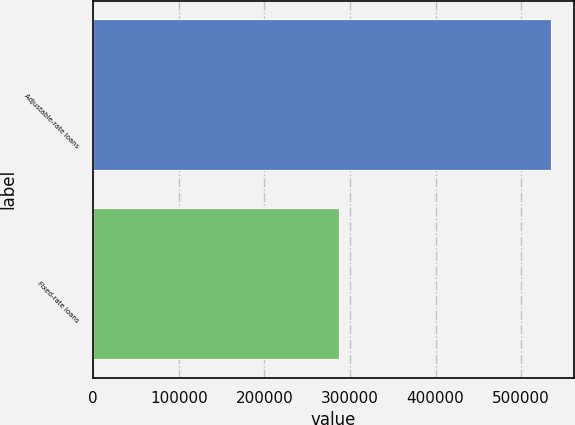<chart> <loc_0><loc_0><loc_500><loc_500><bar_chart><fcel>Adjustable-rate loans<fcel>Fixed-rate loans<nl><fcel>534943<fcel>286894<nl></chart> 